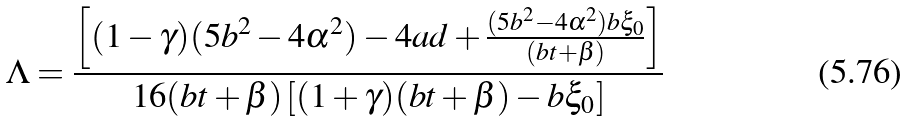<formula> <loc_0><loc_0><loc_500><loc_500>\Lambda = \frac { \left [ ( 1 - \gamma ) ( 5 b ^ { 2 } - 4 \alpha ^ { 2 } ) - 4 a d + \frac { ( 5 b ^ { 2 } - 4 \alpha ^ { 2 } ) b \xi _ { 0 } } { ( b t + \beta ) } \right ] } { 1 6 ( b t + \beta ) \left [ ( 1 + \gamma ) ( b t + \beta ) - b \xi _ { 0 } \right ] }</formula> 